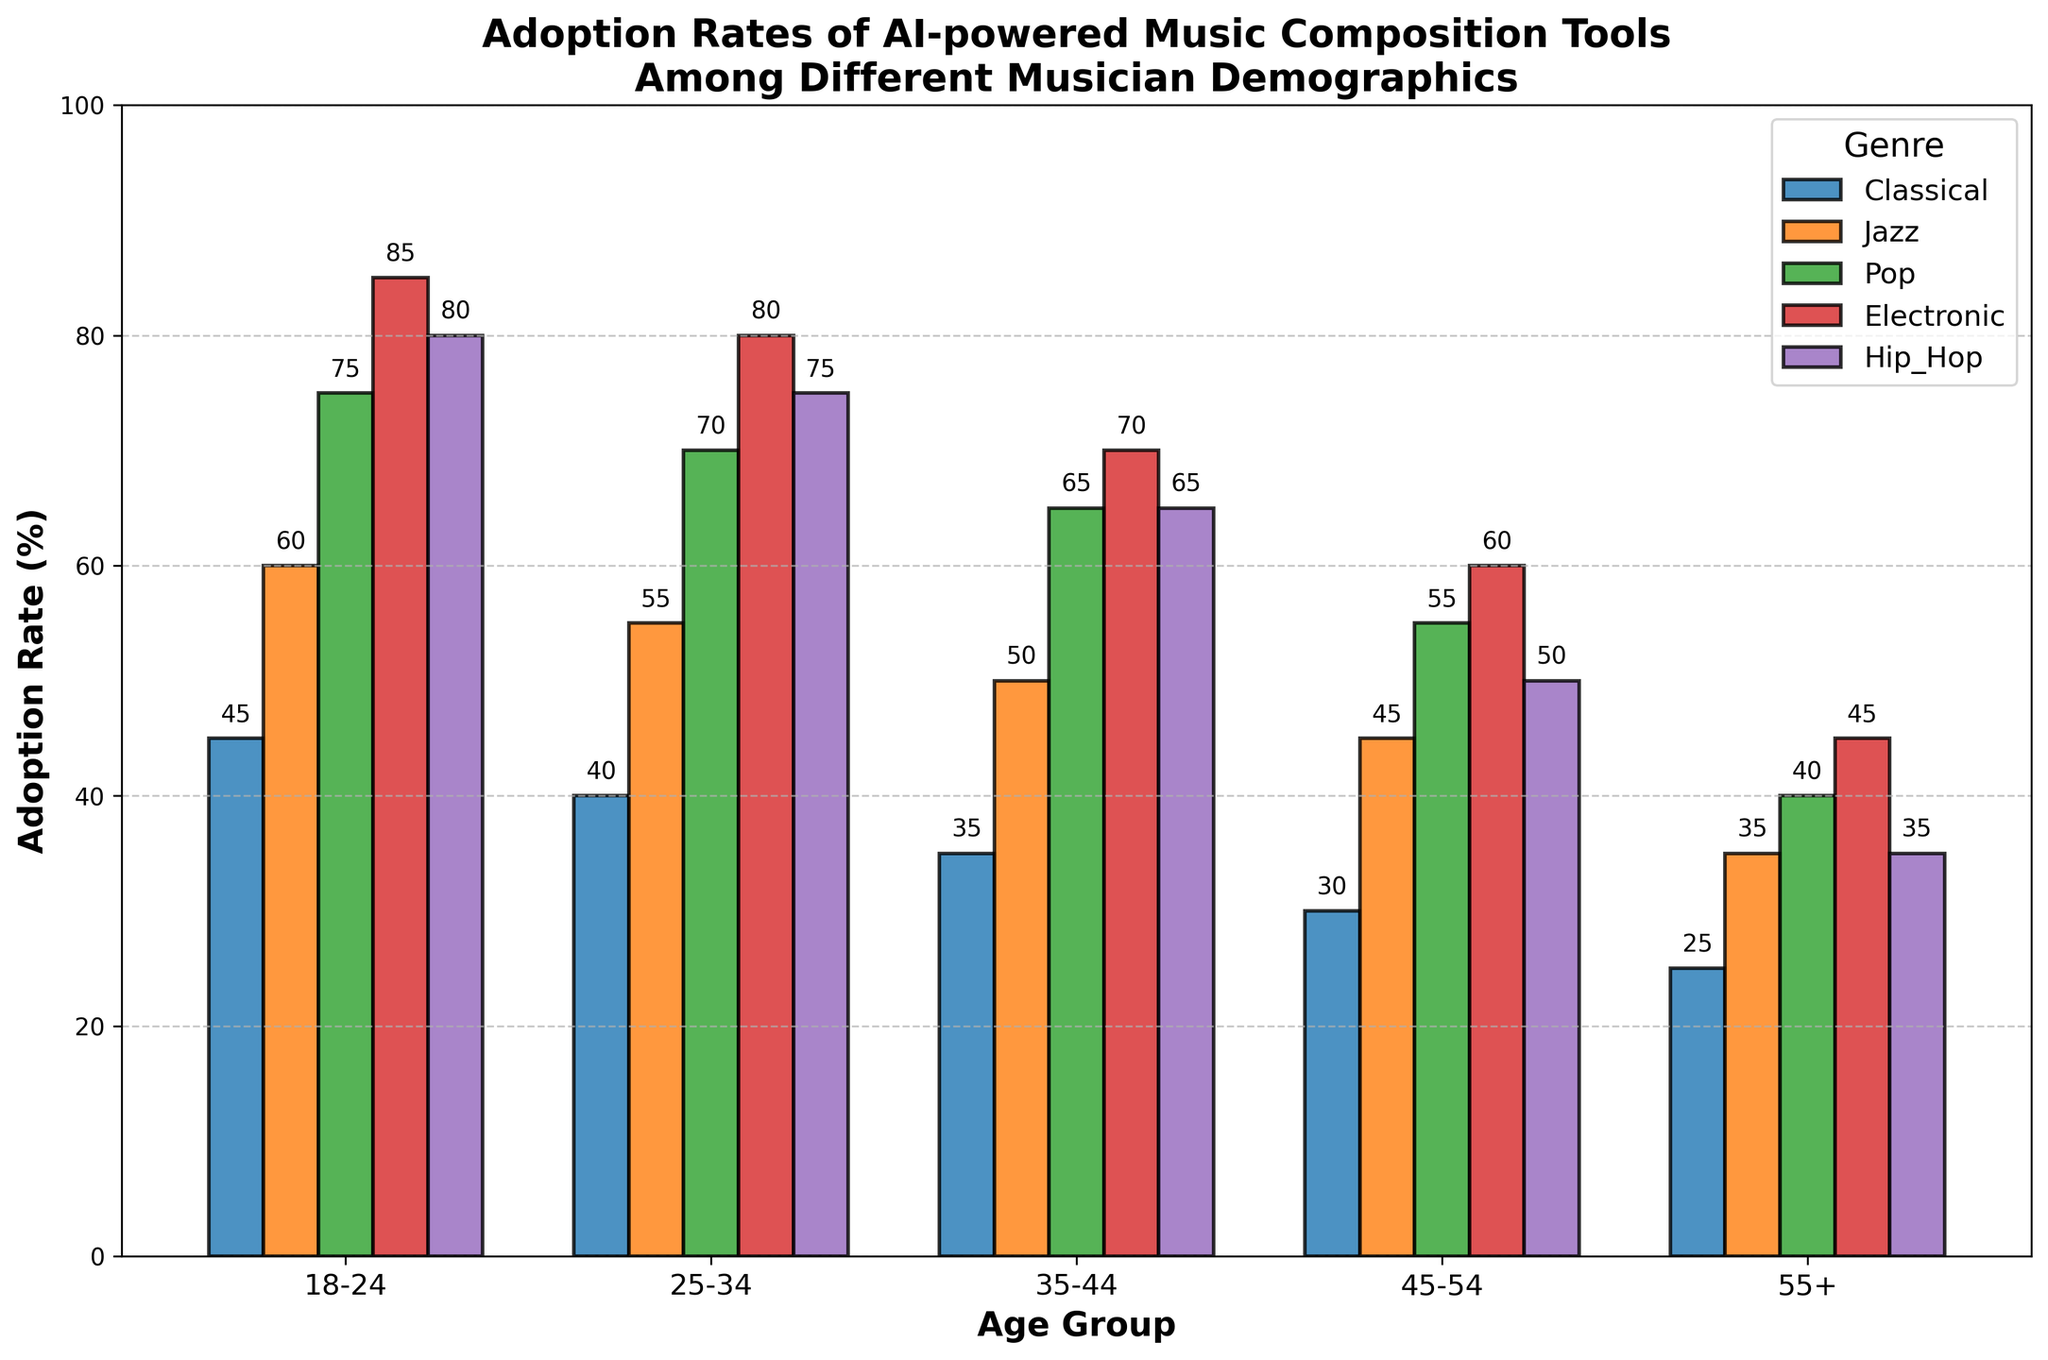What's the adoption rate of Classical music composition tools for the age group 25-34? Referring to the bar labeled 'Classical' and aligned with the '25-34' age group, we see that the height of the bar is at 40. Therefore, the adoption rate is 40%.
Answer: 40% Which genre has the highest adoption rate among musicians aged 18-24? By looking at the bars within the age group '18-24', we observe that 'Electronic' has the tallest bar at 85%.
Answer: Electronic For musicians aged 55+, which genre has the lowest adoption rate? Within the age group '55+', the shortest bar corresponds to 'Classical' at 25%.
Answer: Classical Compare the adoption rates of Jazz and Pop for musicians aged 35-44. Which is higher, and by how much? For the age group '35-44', 'Jazz' has an adoption rate of 50%, and 'Pop' has an adoption rate of 65%. Therefore, 'Pop' is higher by 15%.
Answer: Pop, by 15% What’s the difference in adoption rates for Hip_Hop music composition tools between the 18-24 and 45-54 age groups? The adoption rate of Hip_Hop for 18-24 is 80% and for 45-54 is 50%. The difference is 80% - 50% = 30%.
Answer: 30% Calculate the average adoption rate of AI-powered music composition tools for all genres among musicians aged 25-34. The adoption rates for age group 25-34 are: Classical 40%, Jazz 55%, Pop 70%, Electronic 80%, Hip_Hop 75%. Summing these, 40 + 55 + 70 + 80 + 75 = 320. The average is 320 / 5 = 64%.
Answer: 64% Which age group shows the greatest variability in adoption rates across different genres? By observing the range of adoption rates in each age group: 18-24 ranges from 45% to 85%, 25-34 ranges from 40% to 80%, 35-44 ranges from 35% to 70%, 45-54 ranges from 30% to 60%, and 55+ ranges from 25% to 45%. The age group '18-24' shows the greatest variability, with a range of 40%.
Answer: 18-24 Identify the youngest age group where the adoption rate for Classical music composition tools is lower than 35%. Scanning the 'Classical' bars from youngest to oldest, the adoption rate drops below 35% only at '55+'.
Answer: 55+ 